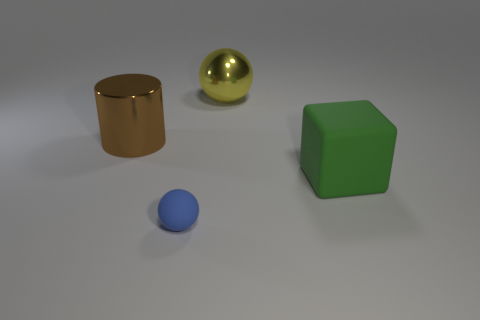How would the scene change if the light source was moved to the opposite side? If the light source in the image were moved to the opposite side, the shadows would fall in the opposite direction, altering the appearance of depth and texture. The highlights on the reflective objects, such as the golden cylinder and the metallic sphere, would shift to the other side, changing the way they draw the viewer's eye. 